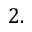<formula> <loc_0><loc_0><loc_500><loc_500>2 .</formula> 